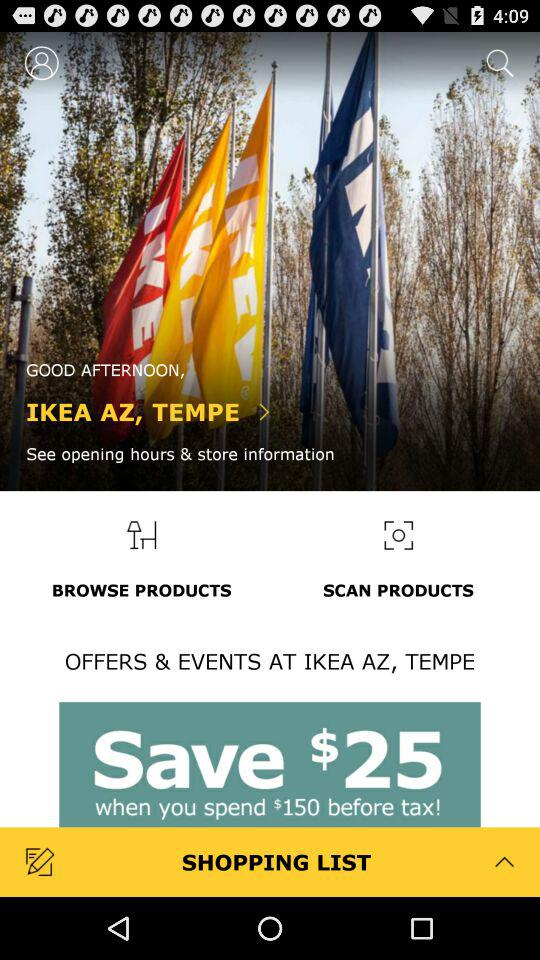What is the name of the store? The name of the store is "IKEA AZ, TEMPE". 